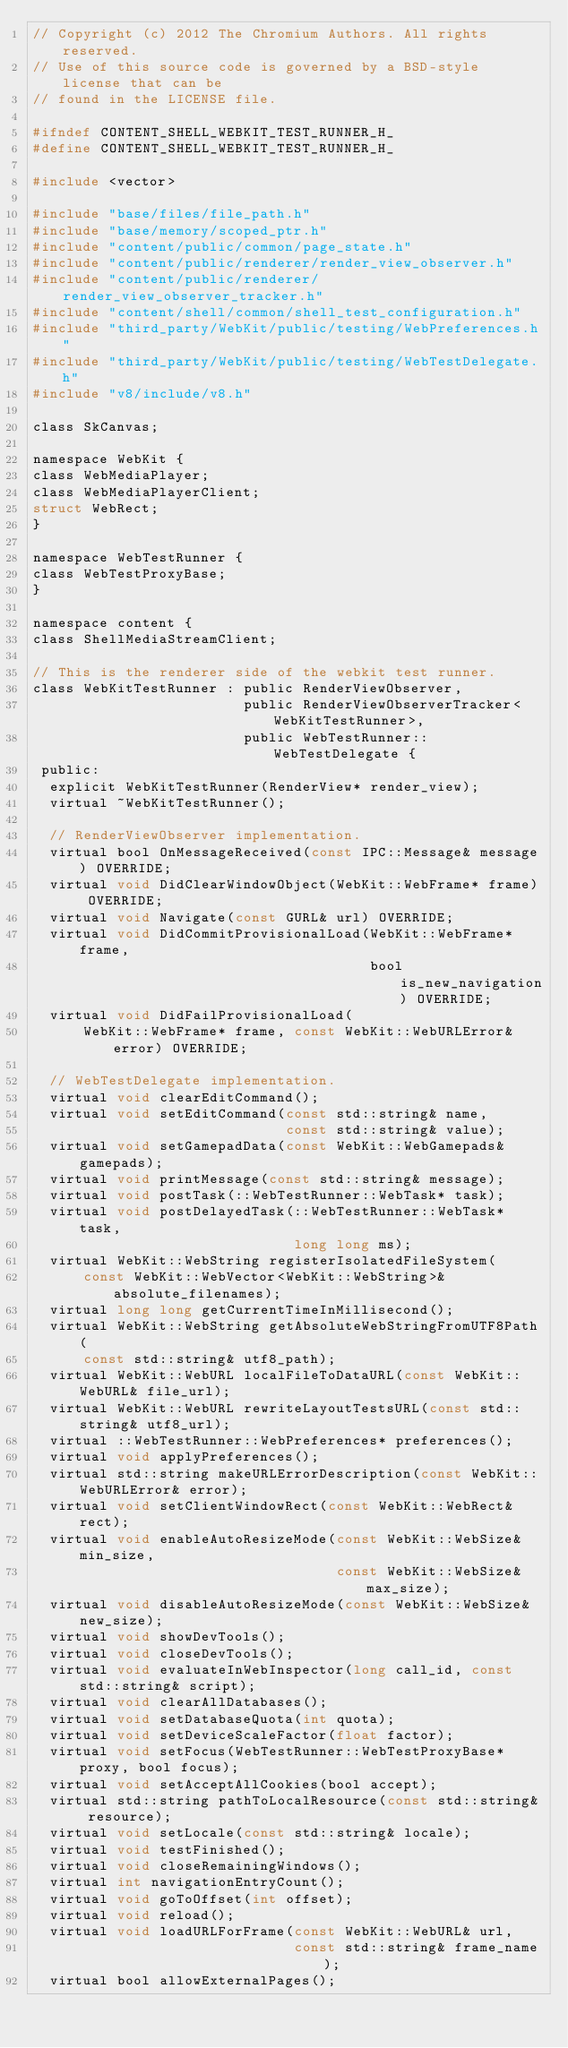Convert code to text. <code><loc_0><loc_0><loc_500><loc_500><_C_>// Copyright (c) 2012 The Chromium Authors. All rights reserved.
// Use of this source code is governed by a BSD-style license that can be
// found in the LICENSE file.

#ifndef CONTENT_SHELL_WEBKIT_TEST_RUNNER_H_
#define CONTENT_SHELL_WEBKIT_TEST_RUNNER_H_

#include <vector>

#include "base/files/file_path.h"
#include "base/memory/scoped_ptr.h"
#include "content/public/common/page_state.h"
#include "content/public/renderer/render_view_observer.h"
#include "content/public/renderer/render_view_observer_tracker.h"
#include "content/shell/common/shell_test_configuration.h"
#include "third_party/WebKit/public/testing/WebPreferences.h"
#include "third_party/WebKit/public/testing/WebTestDelegate.h"
#include "v8/include/v8.h"

class SkCanvas;

namespace WebKit {
class WebMediaPlayer;
class WebMediaPlayerClient;
struct WebRect;
}

namespace WebTestRunner {
class WebTestProxyBase;
}

namespace content {
class ShellMediaStreamClient;

// This is the renderer side of the webkit test runner.
class WebKitTestRunner : public RenderViewObserver,
                         public RenderViewObserverTracker<WebKitTestRunner>,
                         public WebTestRunner::WebTestDelegate {
 public:
  explicit WebKitTestRunner(RenderView* render_view);
  virtual ~WebKitTestRunner();

  // RenderViewObserver implementation.
  virtual bool OnMessageReceived(const IPC::Message& message) OVERRIDE;
  virtual void DidClearWindowObject(WebKit::WebFrame* frame) OVERRIDE;
  virtual void Navigate(const GURL& url) OVERRIDE;
  virtual void DidCommitProvisionalLoad(WebKit::WebFrame* frame,
                                        bool is_new_navigation) OVERRIDE;
  virtual void DidFailProvisionalLoad(
      WebKit::WebFrame* frame, const WebKit::WebURLError& error) OVERRIDE;

  // WebTestDelegate implementation.
  virtual void clearEditCommand();
  virtual void setEditCommand(const std::string& name,
                              const std::string& value);
  virtual void setGamepadData(const WebKit::WebGamepads& gamepads);
  virtual void printMessage(const std::string& message);
  virtual void postTask(::WebTestRunner::WebTask* task);
  virtual void postDelayedTask(::WebTestRunner::WebTask* task,
                               long long ms);
  virtual WebKit::WebString registerIsolatedFileSystem(
      const WebKit::WebVector<WebKit::WebString>& absolute_filenames);
  virtual long long getCurrentTimeInMillisecond();
  virtual WebKit::WebString getAbsoluteWebStringFromUTF8Path(
      const std::string& utf8_path);
  virtual WebKit::WebURL localFileToDataURL(const WebKit::WebURL& file_url);
  virtual WebKit::WebURL rewriteLayoutTestsURL(const std::string& utf8_url);
  virtual ::WebTestRunner::WebPreferences* preferences();
  virtual void applyPreferences();
  virtual std::string makeURLErrorDescription(const WebKit::WebURLError& error);
  virtual void setClientWindowRect(const WebKit::WebRect& rect);
  virtual void enableAutoResizeMode(const WebKit::WebSize& min_size,
                                    const WebKit::WebSize& max_size);
  virtual void disableAutoResizeMode(const WebKit::WebSize& new_size);
  virtual void showDevTools();
  virtual void closeDevTools();
  virtual void evaluateInWebInspector(long call_id, const std::string& script);
  virtual void clearAllDatabases();
  virtual void setDatabaseQuota(int quota);
  virtual void setDeviceScaleFactor(float factor);
  virtual void setFocus(WebTestRunner::WebTestProxyBase* proxy, bool focus);
  virtual void setAcceptAllCookies(bool accept);
  virtual std::string pathToLocalResource(const std::string& resource);
  virtual void setLocale(const std::string& locale);
  virtual void testFinished();
  virtual void closeRemainingWindows();
  virtual int navigationEntryCount();
  virtual void goToOffset(int offset);
  virtual void reload();
  virtual void loadURLForFrame(const WebKit::WebURL& url,
                               const std::string& frame_name);
  virtual bool allowExternalPages();</code> 